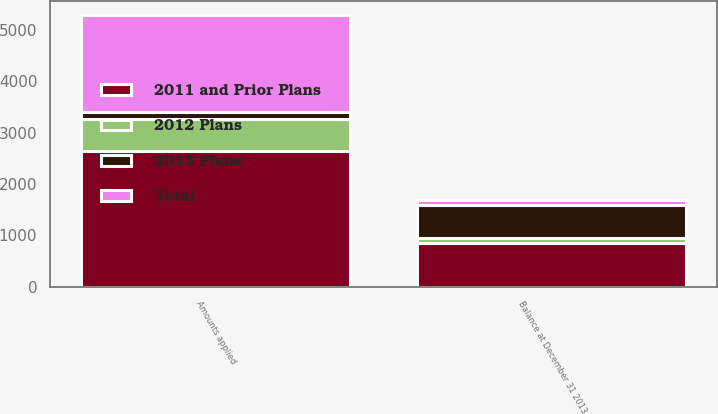<chart> <loc_0><loc_0><loc_500><loc_500><stacked_bar_chart><ecel><fcel>Amounts applied<fcel>Balance at December 31 2013<nl><fcel>2013 Plans<fcel>136<fcel>656<nl><fcel>2012 Plans<fcel>626<fcel>92<nl><fcel>Total<fcel>1887<fcel>98<nl><fcel>2011 and Prior Plans<fcel>2649<fcel>846<nl></chart> 